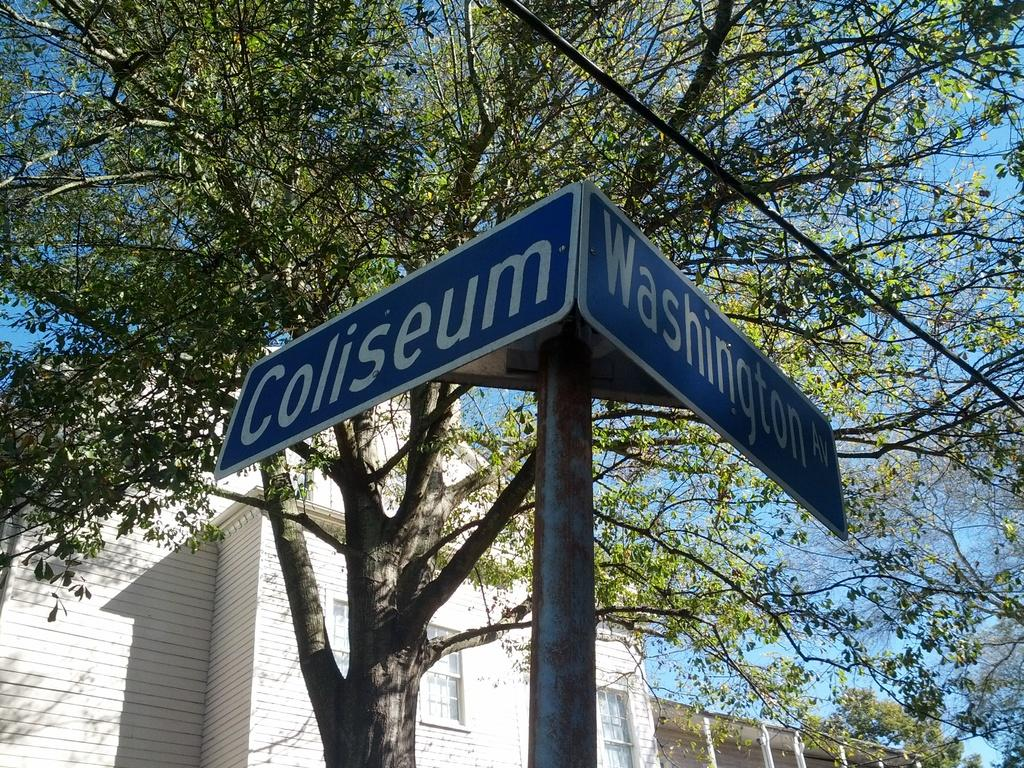What is the main structure in the image? There is a pole in the image with two boards attached to it. What is written on the boards? There is text on the boards. What can be seen in the background of the image? There is a tree and a building in the background of the image. How does the flesh on the pole appear in the image? There is no flesh present in the image; it features a pole with boards and text. 